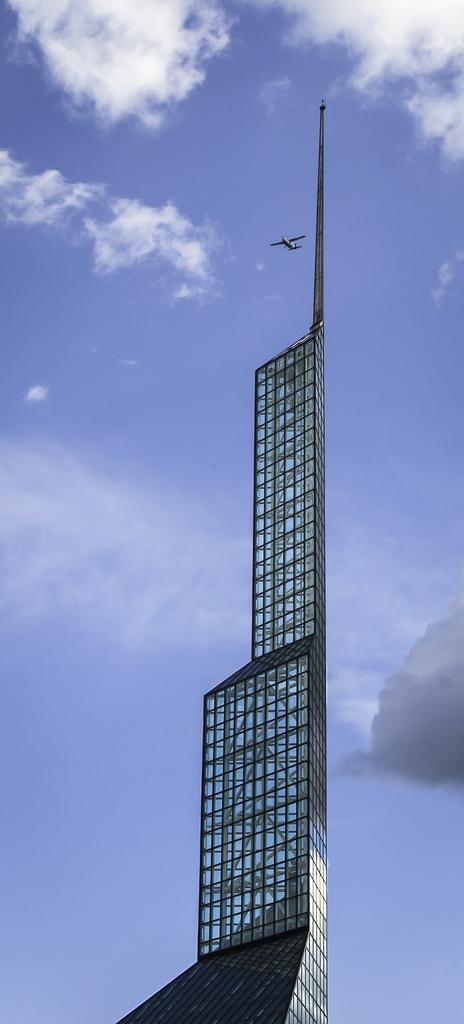Describe this image in one or two sentences. In the image there is a high- rise building and there is a plane flying in the sky. 